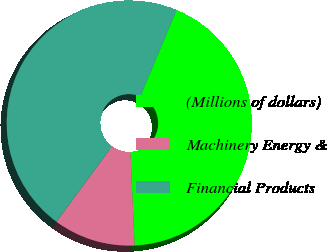Convert chart. <chart><loc_0><loc_0><loc_500><loc_500><pie_chart><fcel>(Millions of dollars)<fcel>Machinery Energy &<fcel>Financial Products<nl><fcel>42.95%<fcel>10.83%<fcel>46.22%<nl></chart> 